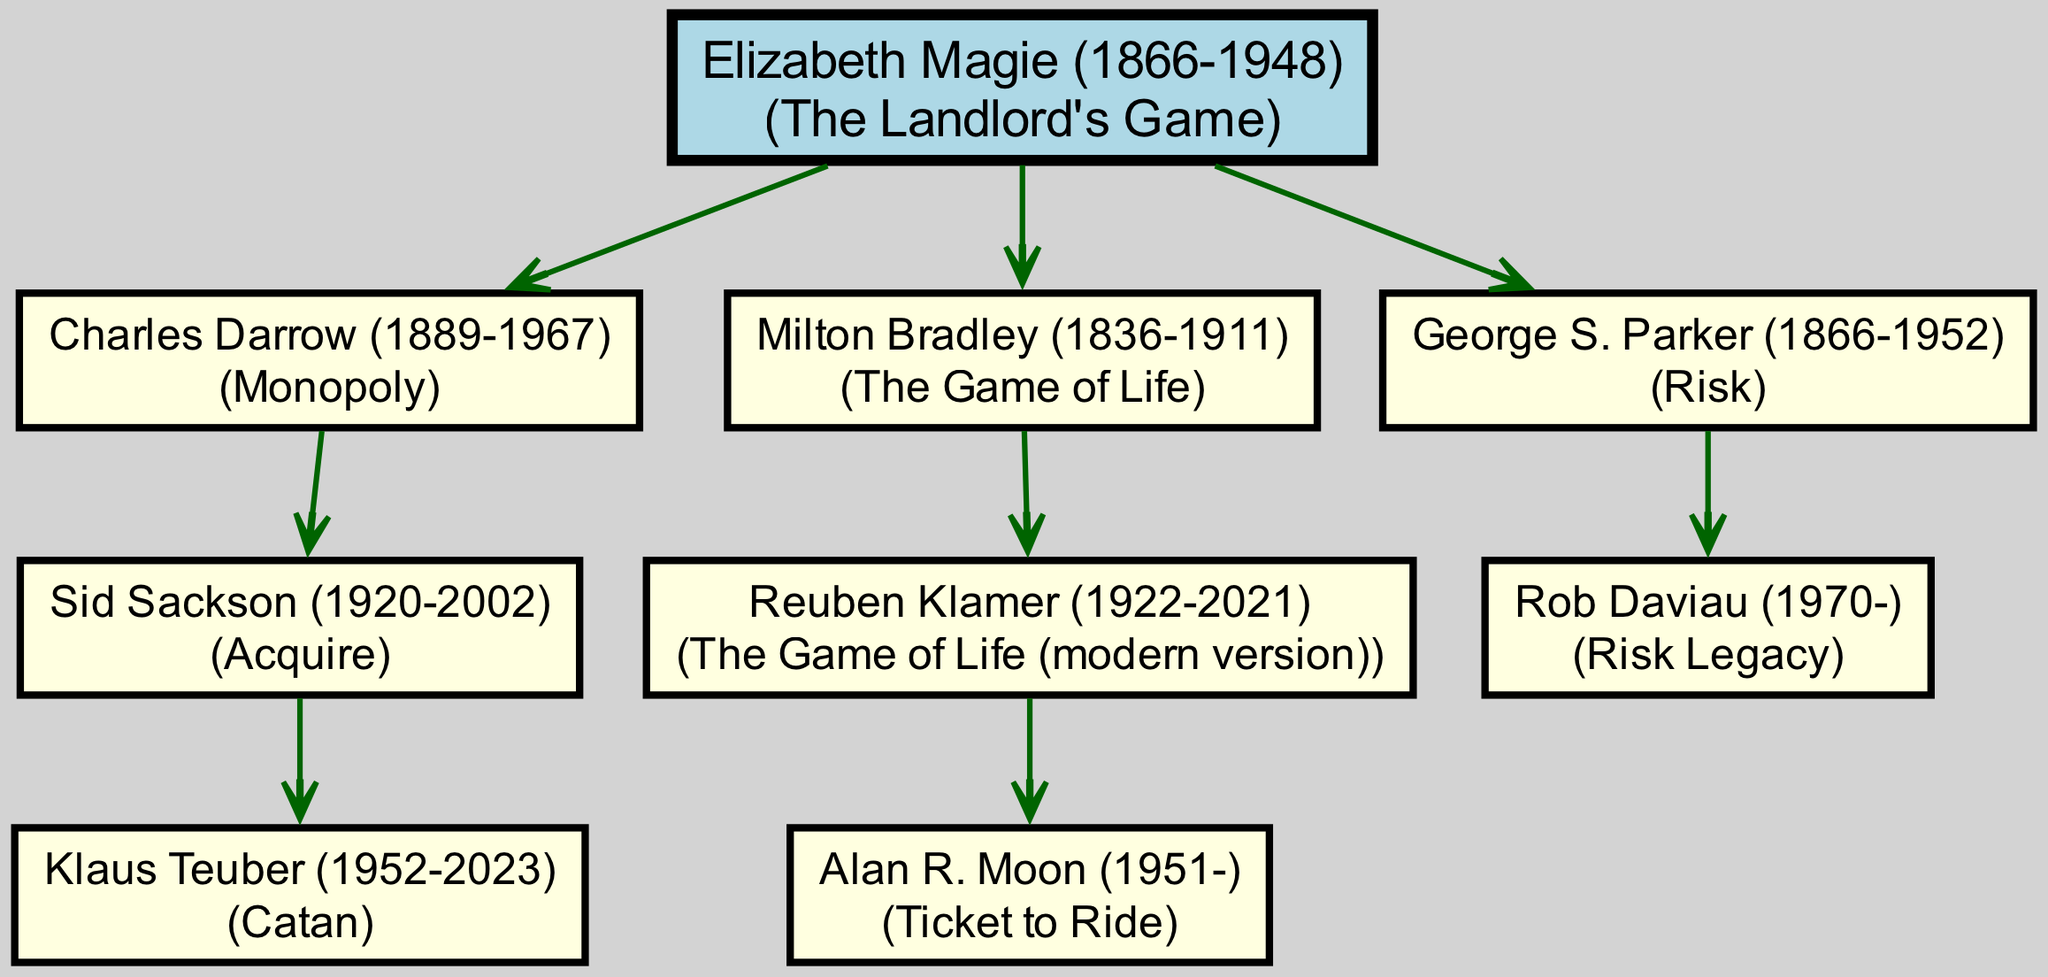What is the root of the family tree? The root of the family tree is indicated at the top of the diagram and shows Elizabeth Magie as the starting point of this lineage.
Answer: Elizabeth Magie How many children did Charles Darrow have? Charles Darrow is shown with one child in the diagram, specifically Sid Sackson, who is the only child listed under him.
Answer: 1 Which game is associated with George S. Parker? The diagram explicitly lists the game associated with George S. Parker as Risk, next to his name in the diagram.
Answer: Risk Who created the modern version of The Game of Life? Looking at the diagram, Reuben Klamer is noted as the creator of the modern version of The Game of Life, following Milton Bradley in the hierarchy.
Answer: Reuben Klamer Which game did Klaus Teuber design? Klaus Teuber's name is connected to and labeled with Catan in the hierarchy, clearly indicating his contribution to board games.
Answer: Catan What is the relationship between Elizabeth Magie and Klaus Teuber? To find this relationship, you must trace the lineage from the root Elizabeth Magie down through Charles Darrow to Sid Sackson, and then to Klaus Teuber; this shows that Elizabeth Magie is the great-grandparent of Klaus Teuber in this family tree.
Answer: Great-grandparent How many generations are shown in the tree? By examining the levels from the root (Elizabeth Magie) down to her descendants (Charles Darrow, Milton Bradley, George S. Parker) and their children, it shows that there are three generations visible in this family tree.
Answer: 3 Which designer is listed immediately below Sid Sackson? The diagram shows Klaus Teuber as the child connected immediately under Sid Sackson, indicating his position as a direct descendant.
Answer: Klaus Teuber What game did Alan R. Moon create? Alan R. Moon is explicitly named in the diagram and associated with the game Ticket to Ride, which is shown directly underneath his name.
Answer: Ticket to Ride 